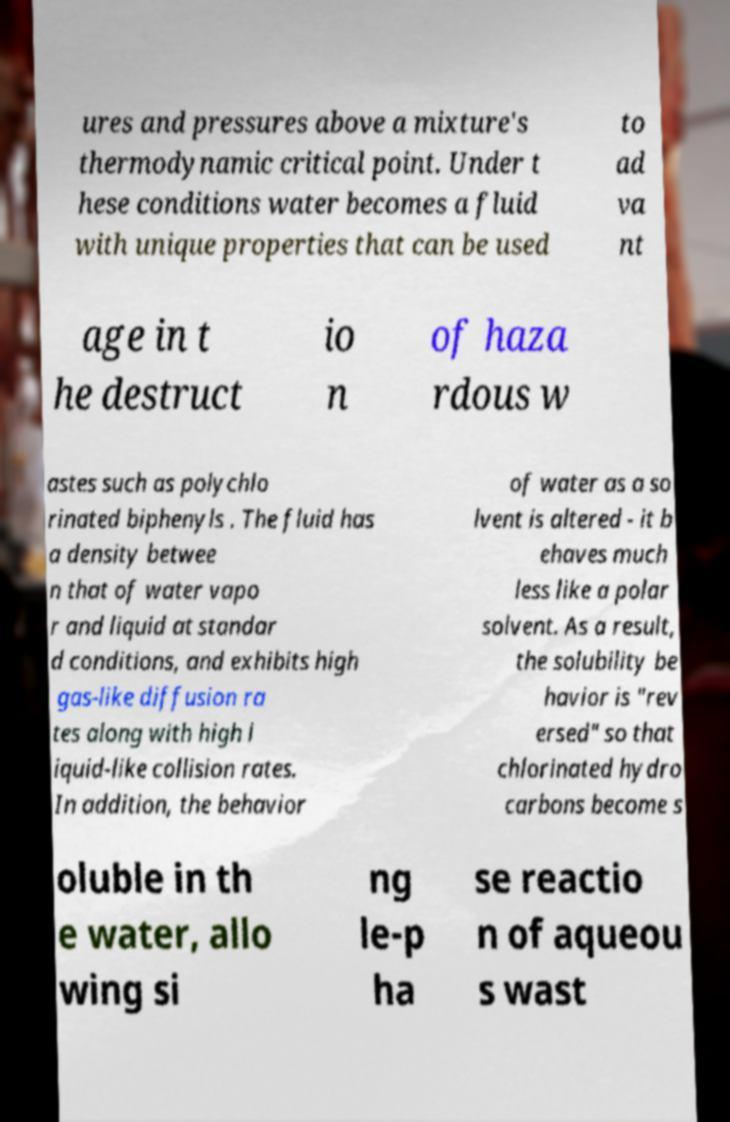Please read and relay the text visible in this image. What does it say? ures and pressures above a mixture's thermodynamic critical point. Under t hese conditions water becomes a fluid with unique properties that can be used to ad va nt age in t he destruct io n of haza rdous w astes such as polychlo rinated biphenyls . The fluid has a density betwee n that of water vapo r and liquid at standar d conditions, and exhibits high gas-like diffusion ra tes along with high l iquid-like collision rates. In addition, the behavior of water as a so lvent is altered - it b ehaves much less like a polar solvent. As a result, the solubility be havior is "rev ersed" so that chlorinated hydro carbons become s oluble in th e water, allo wing si ng le-p ha se reactio n of aqueou s wast 